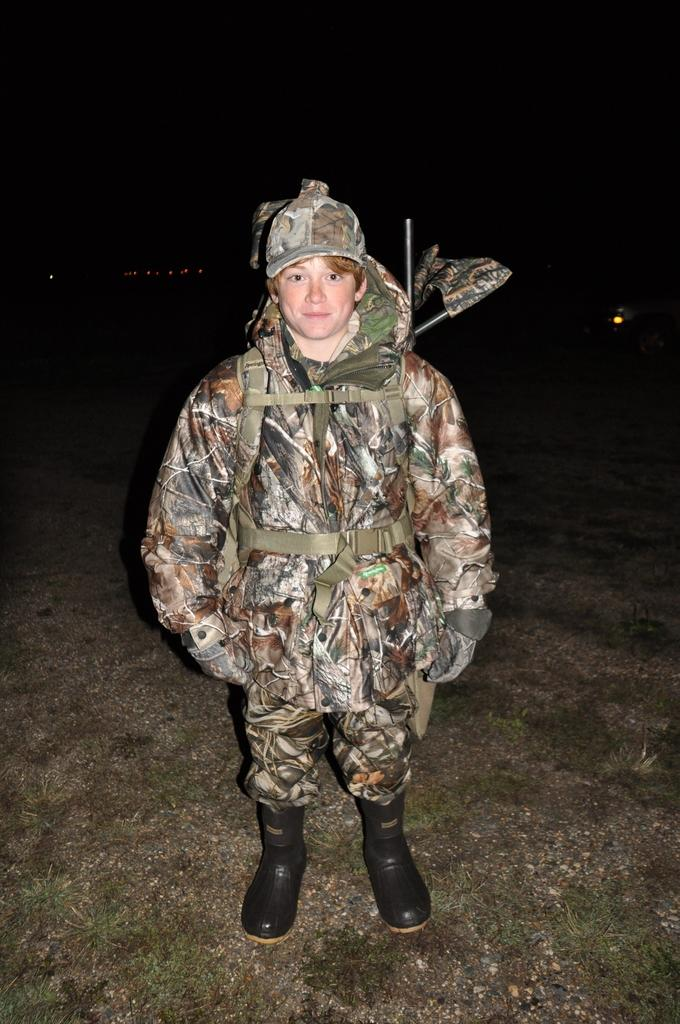What is the main subject of the image? There is a man standing in the image. What is the man standing on? The man is standing on the ground. What is the man wearing? The man is wearing a uniform. What else can be seen in the image besides the man? There are other objects present in the image. How would you describe the background of the image? The background of the image is dark. What type of shoes is the man wearing in the image? The provided facts do not mention any shoes, so we cannot determine the type of shoes the man is wearing. 